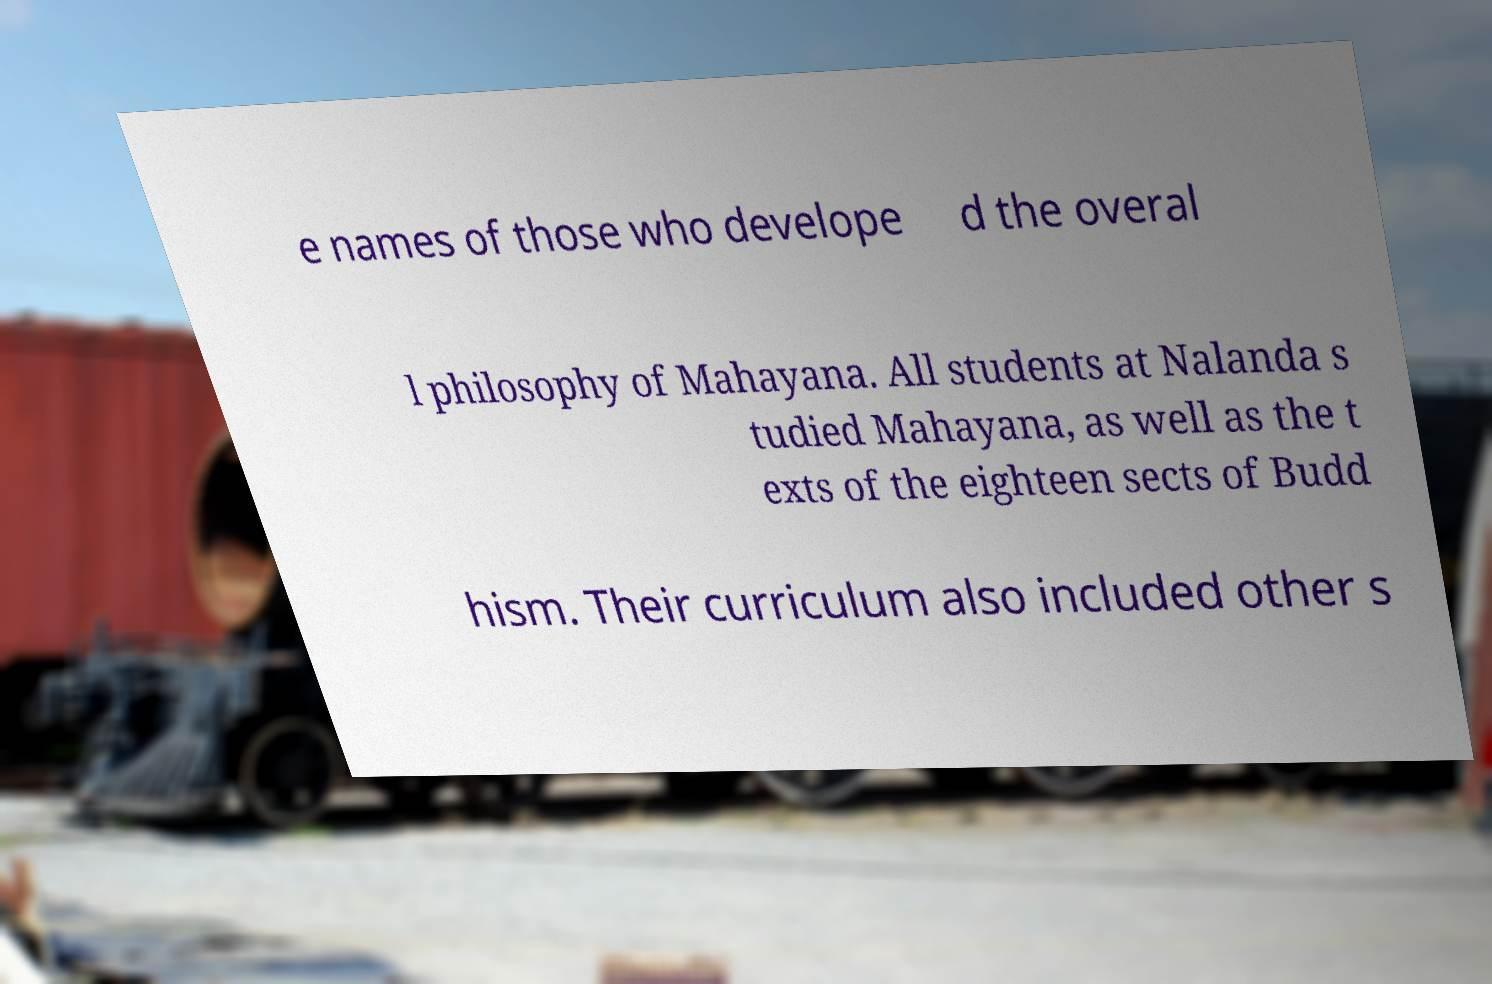I need the written content from this picture converted into text. Can you do that? e names of those who develope d the overal l philosophy of Mahayana. All students at Nalanda s tudied Mahayana, as well as the t exts of the eighteen sects of Budd hism. Their curriculum also included other s 